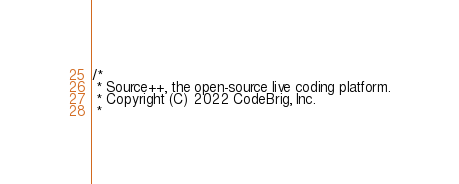Convert code to text. <code><loc_0><loc_0><loc_500><loc_500><_Kotlin_>/*
 * Source++, the open-source live coding platform.
 * Copyright (C) 2022 CodeBrig, Inc.
 *</code> 